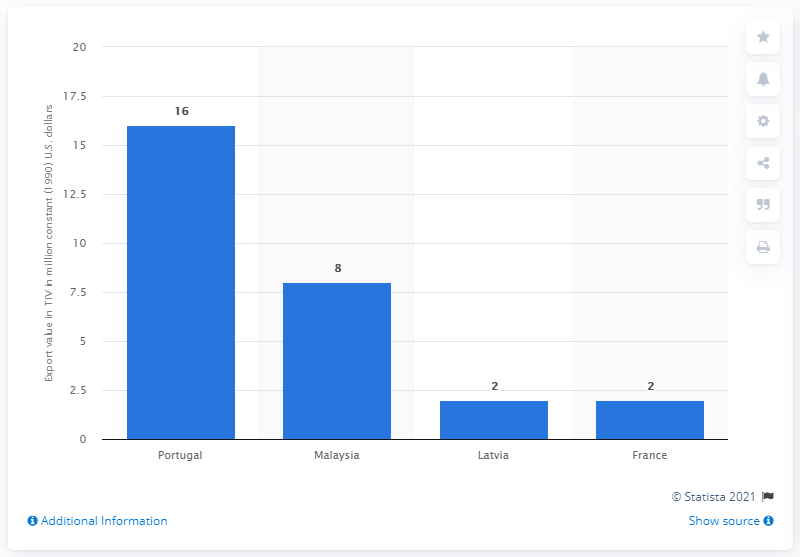Give some essential details in this illustration. In 2018, the amount of constant U.S. dollars that were exported from Denmark to Portugal for arms was 16... 